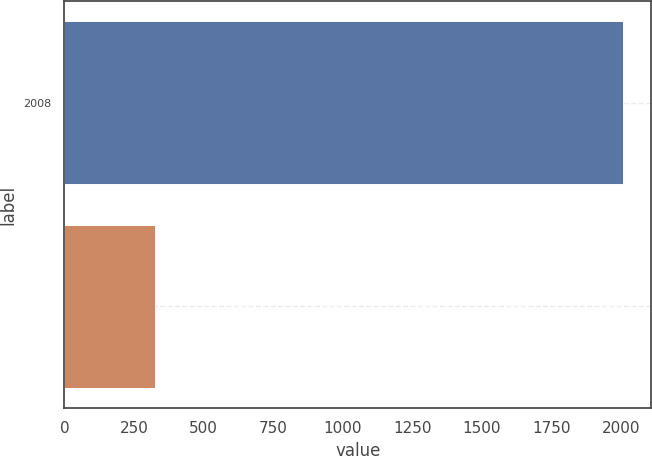<chart> <loc_0><loc_0><loc_500><loc_500><bar_chart><fcel>2008<fcel>Unnamed: 1<nl><fcel>2007<fcel>326<nl></chart> 